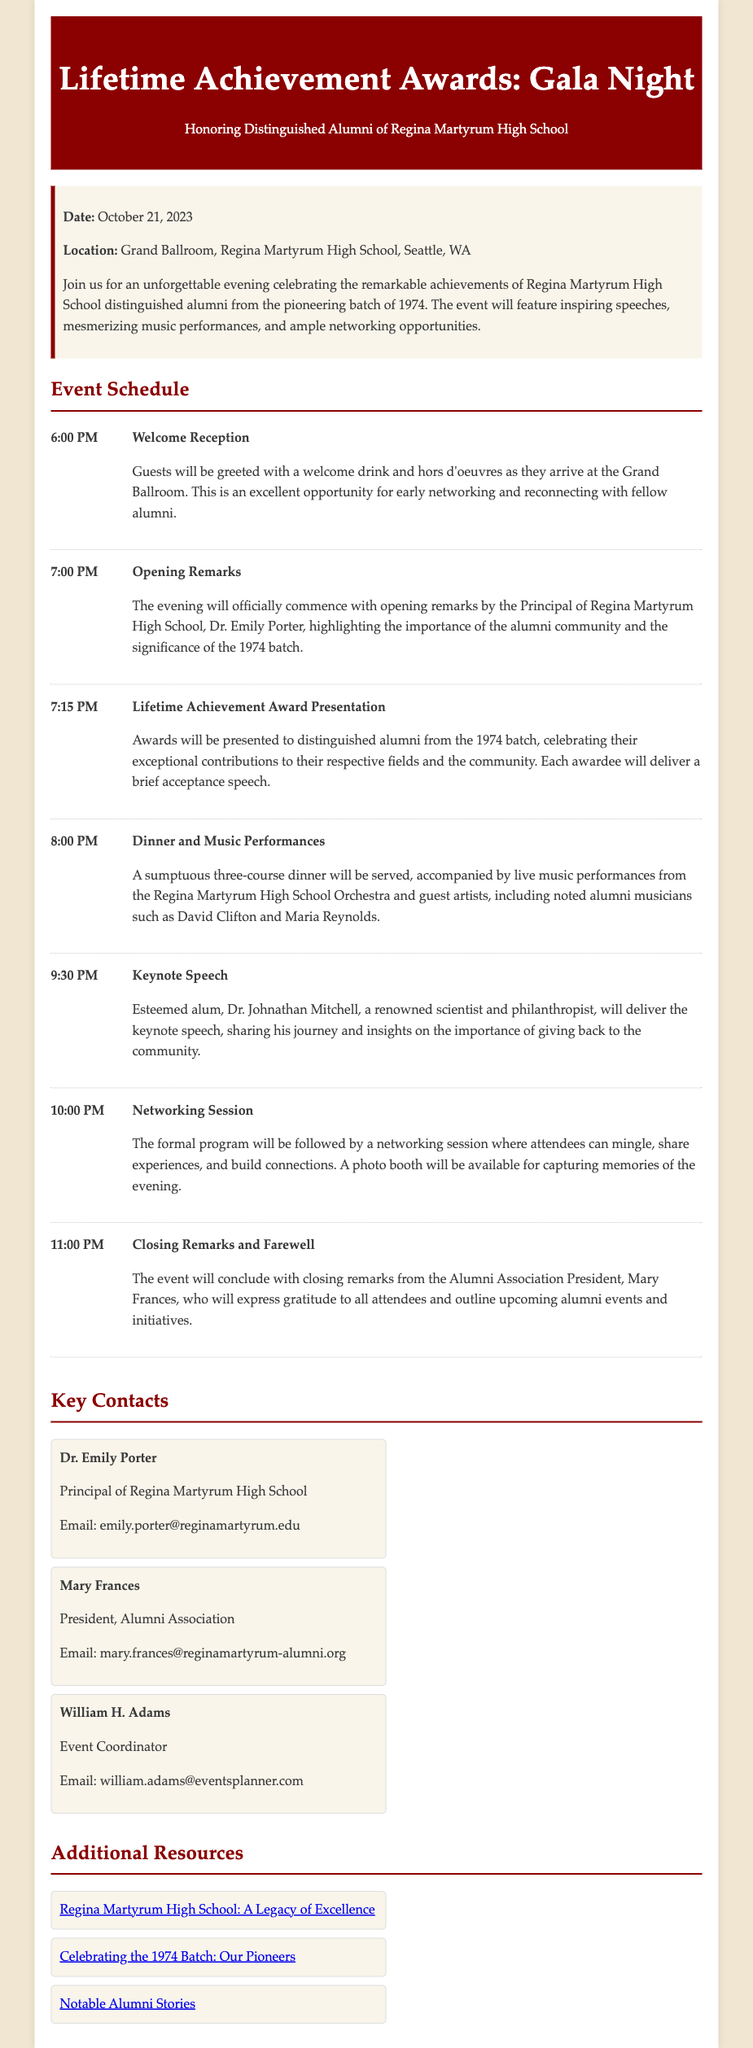What is the date of the Gala Night? The date is specified in the event information section of the document.
Answer: October 21, 2023 Where is the event taking place? The location of the event is mentioned under the event information section.
Answer: Grand Ballroom, Regina Martyrum High School, Seattle, WA Who will give the keynote speech? The name of the speaker for the keynote speech is provided in the schedule section.
Answer: Dr. Johnathan Mitchell What activity starts at 8:00 PM? The schedule details what occurs at that specific time.
Answer: Dinner and Music Performances What is the name of the President of the Alumni Association? The document lists the key contacts, including their titles and names.
Answer: Mary Frances Which year is being celebrated for the distinguished alumni? The document states the batch year that is being honored, specifically in the opening paragraphs.
Answer: 1974 How long is the welcome reception scheduled to last? The schedule provides the start and end timing for various activities.
Answer: 1 hour What type of dinner will be served? The type of dinner is described in the dinner activity section of the itinerary.
Answer: Three-course dinner 